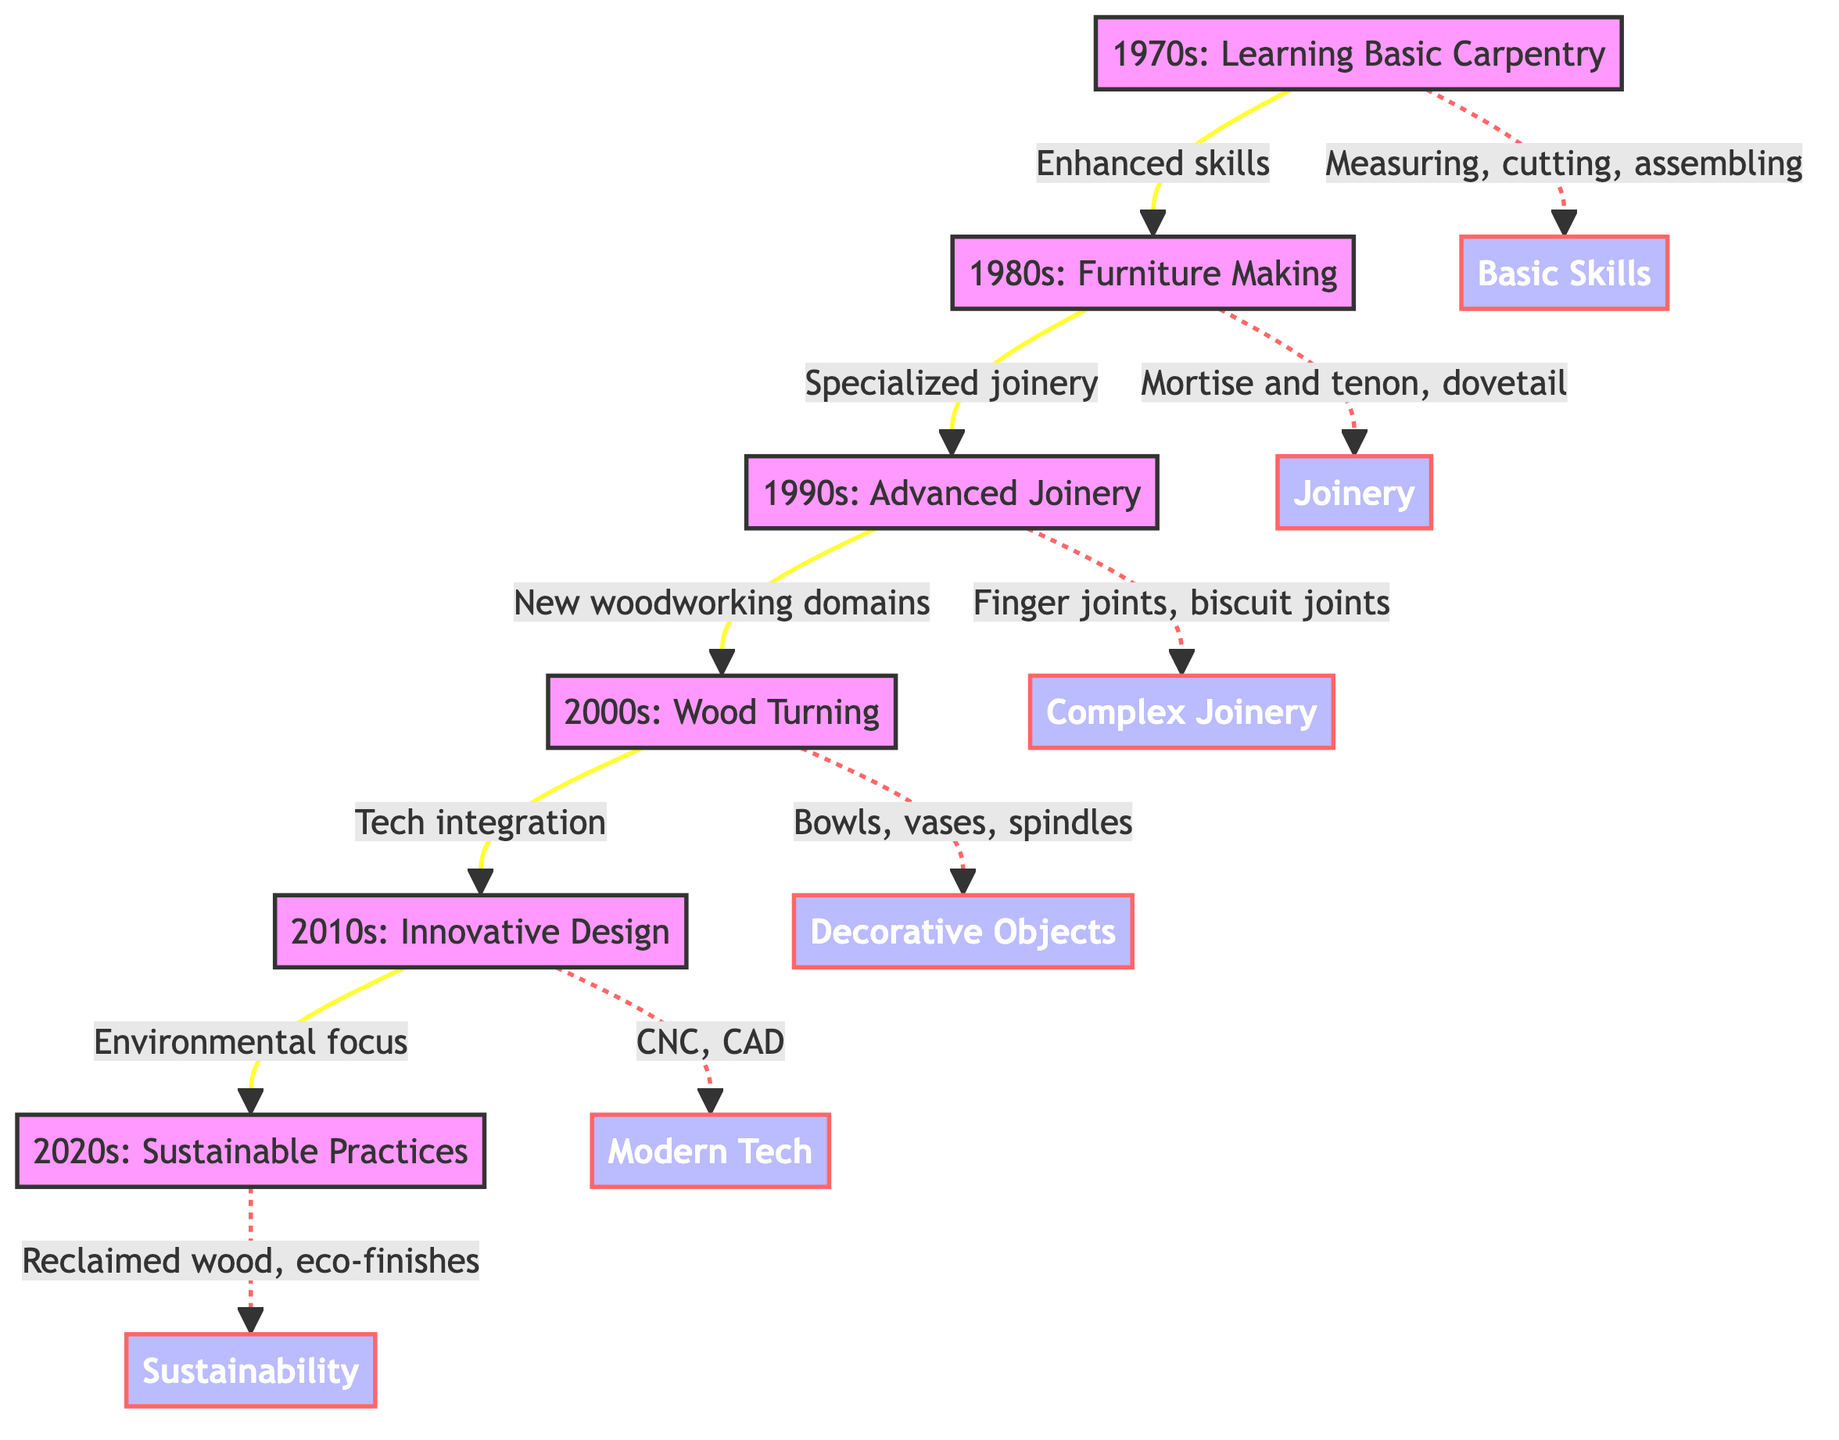What techniques are introduced in the 1980s? The node for the 1980s states that it focuses on furniture making and includes skills such as mortise and tenon joints, dovetail joints, and finishing methods. This is a direct connection from the 1980s node to its description.
Answer: Furniture Making Which decade introduced wood turning? The 2000s node clearly indicates that this decade involved learning wood turning. This is a straightforward reading of the node information.
Answer: 2000s How many nodes are in this diagram? By counting the listed nodes (foundational skills, furniture making, advanced joinery, wood turning, innovative design, sustainable practices), we can see that there are six distinct nodes in the diagram.
Answer: Six What is the relationship between Advanced Joinery and Wood Turning? The edge connecting Advanced Joinery (1990s) to Wood Turning (2000s) is labeled "New woodworking domains," indicating that the progression of techniques led into this new area of woodworking.
Answer: New woodworking domains In which decade did the focus shift to sustainable practices? The 2020s node in the diagram indicates a focus on sustainable practices, highlighting the use of reclaimed wood and eco-friendly techniques. This matches the given information in that node.
Answer: 2020s What skill was learned in the 2010s? The node for the 2010s specifies that this decade focused on innovative design, particularly using modern technology like CNC machines and CAD software. This concludes that the primary skill associated with this decade is modern tech.
Answer: Modern Tech How do skills develop from the 1970s to the 1980s? The connection labeled "Enhanced skills" indicates that skills learned in the 1970s provided a foundation that was built upon with more specific techniques in furniture making during the 1980s. This shows a clear progression from basic skills to enhanced skills.
Answer: Enhanced skills What type of joinery is specifically mentioned in the 1990s? The 1990s node highlights the mastery of complex joinery techniques, specifically finger joints and biscuit joints, as part of the skills gained in that decade. This is identified directly from the node description.
Answer: Complex Joinery 